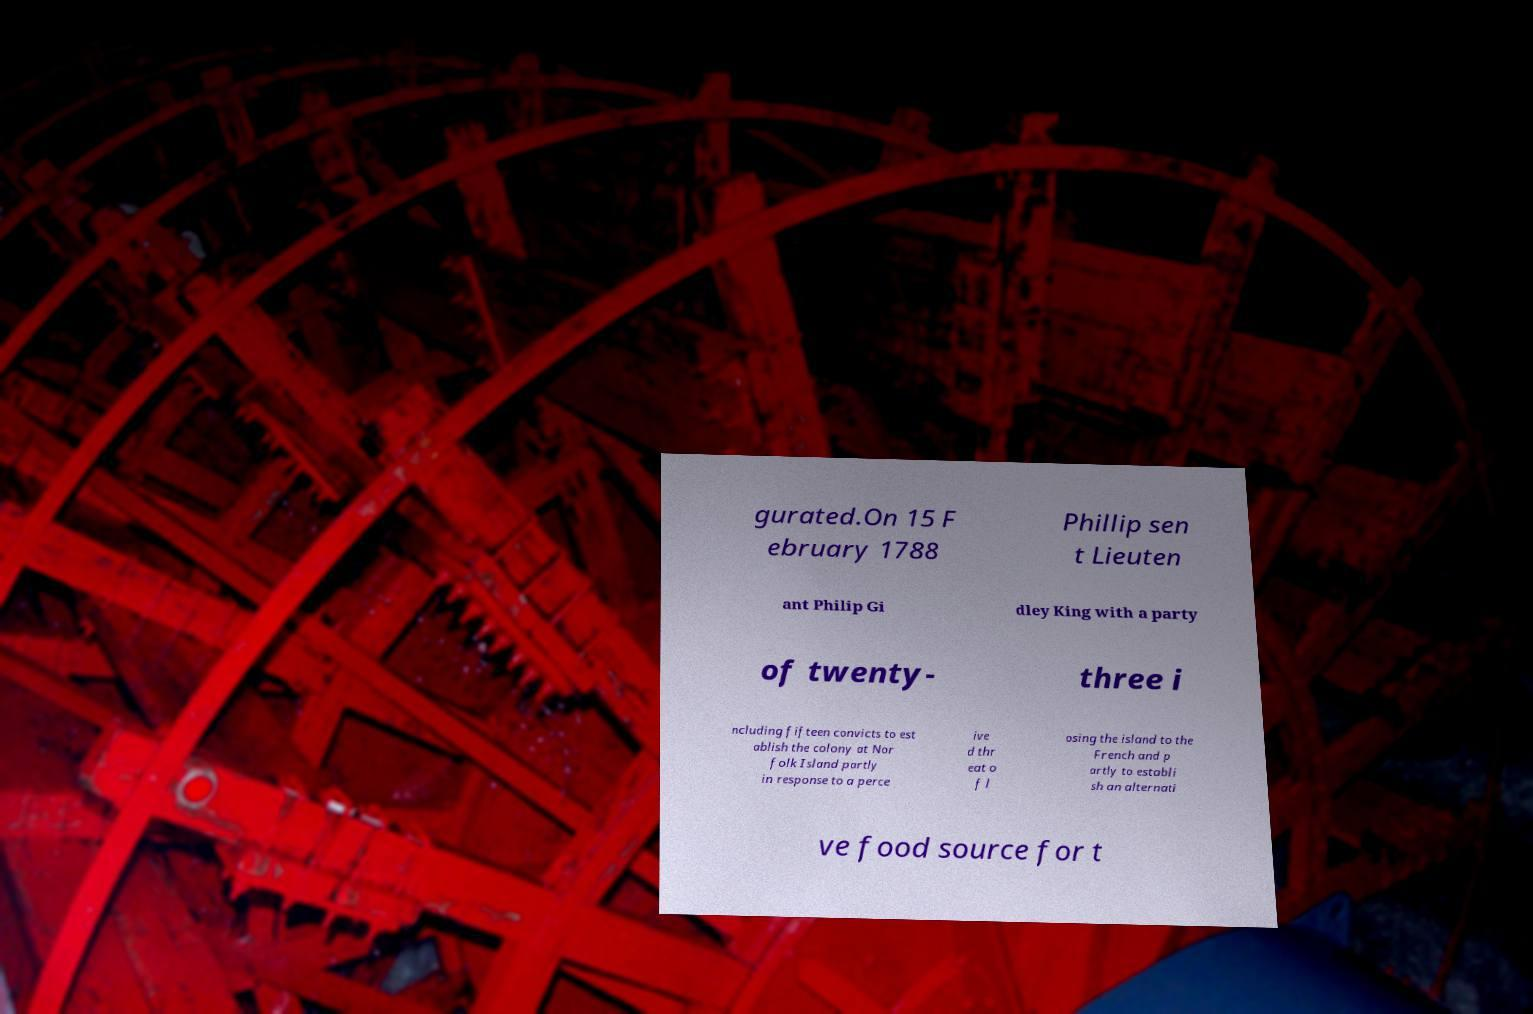There's text embedded in this image that I need extracted. Can you transcribe it verbatim? gurated.On 15 F ebruary 1788 Phillip sen t Lieuten ant Philip Gi dley King with a party of twenty- three i ncluding fifteen convicts to est ablish the colony at Nor folk Island partly in response to a perce ive d thr eat o f l osing the island to the French and p artly to establi sh an alternati ve food source for t 